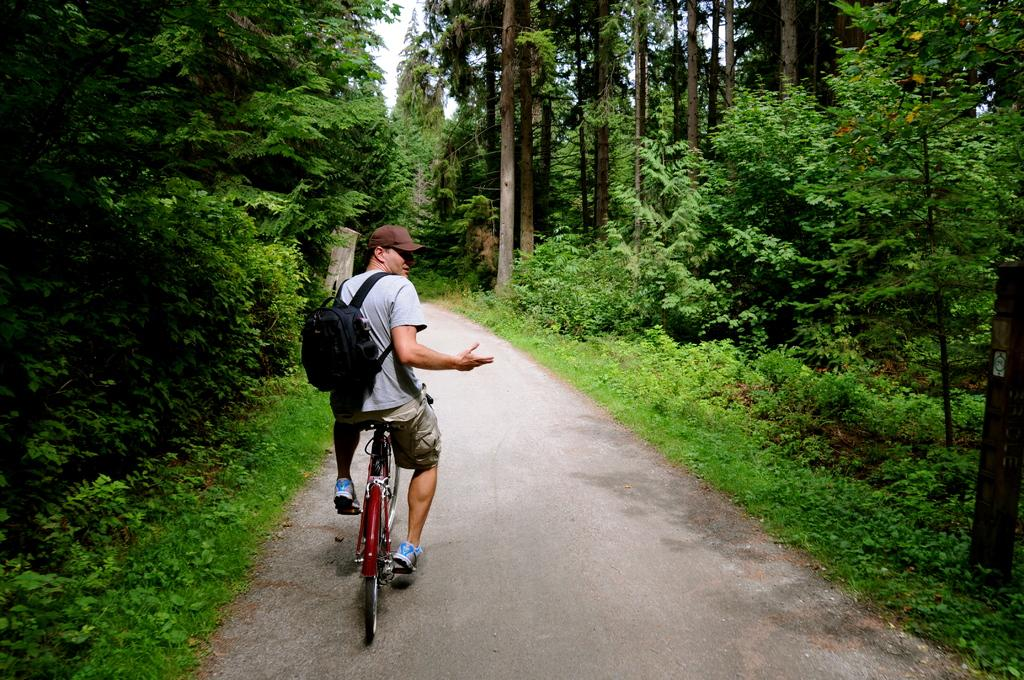What is the man doing in the image? The man is riding a cycle on the road. What is the man wearing on his back? The man is wearing a black bag. What type of headwear is the man wearing? The man is wearing a brown hat. What can be seen on either side of the road in the image? There are plenty of trees and plants on either side of the road. What type of pear is hanging from the tree on the right side of the road? There is no pear visible in the image; only trees and plants are mentioned on either side of the road. 